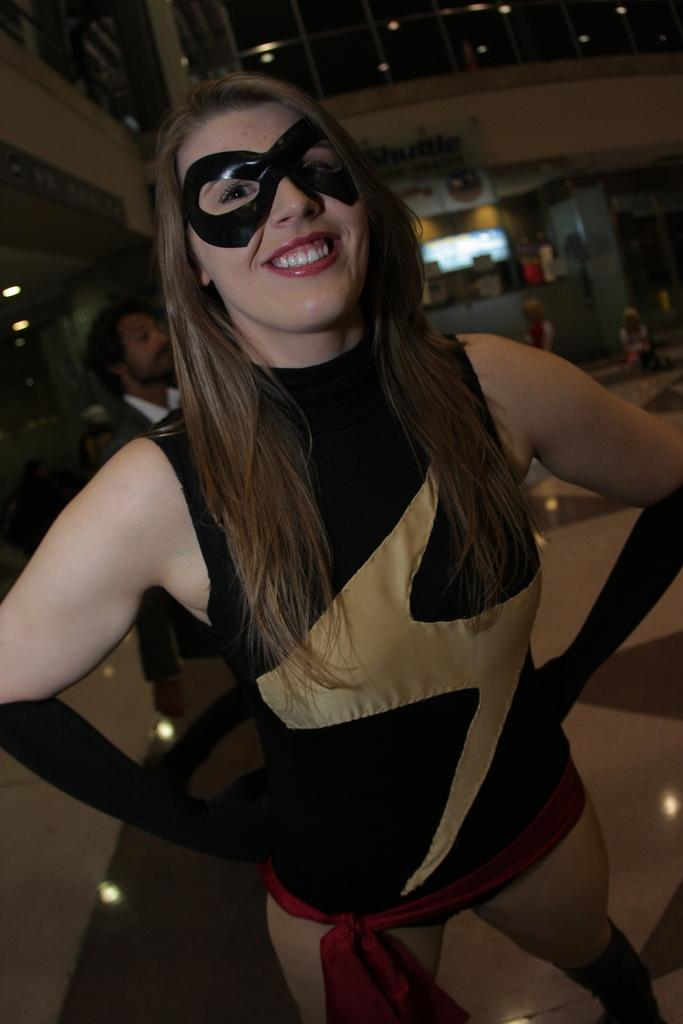Who is the main subject in the image? There is a woman in the image. What is the woman wearing? The woman is wearing a black dress. What can be seen in the background of the image? There is a wall and lights in the background of the image. How would you describe the lighting in the image? The image appears to be slightly dark. What type of hat is the woman wearing in the image? There is no hat visible in the image; the woman is wearing a black dress. What kind of club does the woman belong to in the image? There is no indication of any clubs or organizations in the image; it simply features a woman wearing a black dress with a background of a wall and lights. 